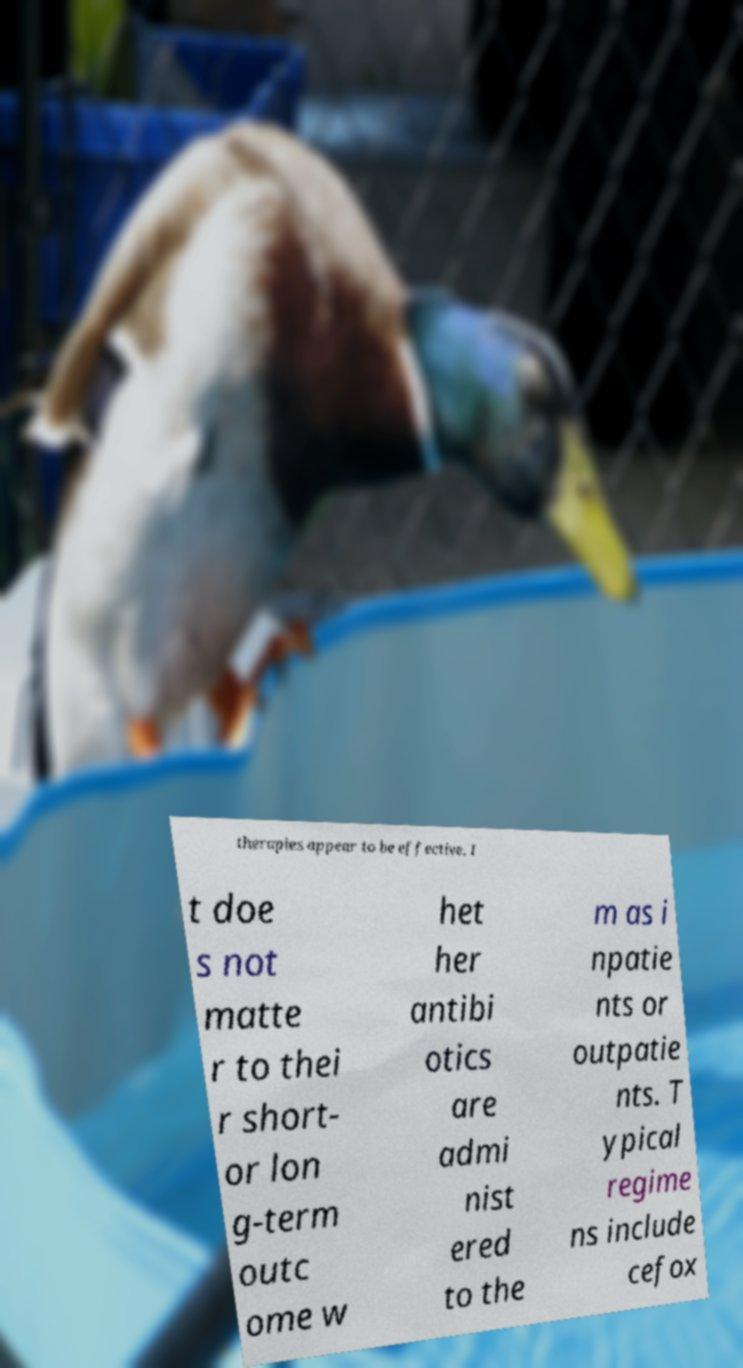There's text embedded in this image that I need extracted. Can you transcribe it verbatim? therapies appear to be effective. I t doe s not matte r to thei r short- or lon g-term outc ome w het her antibi otics are admi nist ered to the m as i npatie nts or outpatie nts. T ypical regime ns include cefox 